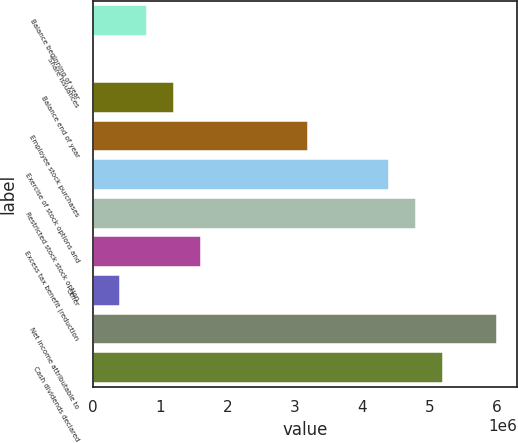<chart> <loc_0><loc_0><loc_500><loc_500><bar_chart><fcel>Balance beginning of year<fcel>Share issuances<fcel>Balance end of year<fcel>Employee stock purchases<fcel>Exercise of stock options and<fcel>Restricted stock stock option<fcel>Excess tax benefit (reduction<fcel>Other<fcel>Net income attributable to<fcel>Cash dividends declared<nl><fcel>799687<fcel>25<fcel>1.19952e+06<fcel>3.19867e+06<fcel>4.39817e+06<fcel>4.798e+06<fcel>1.59935e+06<fcel>399856<fcel>5.99749e+06<fcel>5.19783e+06<nl></chart> 